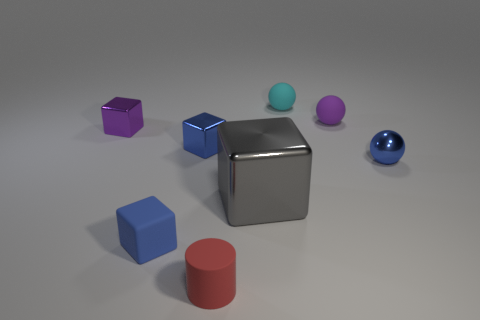Is there any other thing that has the same size as the gray object?
Your answer should be very brief. No. Is the number of cyan spheres in front of the small cyan thing greater than the number of small purple rubber objects?
Provide a succinct answer. No. Do the big metallic object and the red thing have the same shape?
Ensure brevity in your answer.  No. The purple rubber object has what size?
Ensure brevity in your answer.  Small. Is the number of red matte things left of the red matte cylinder greater than the number of tiny metal things that are behind the tiny purple ball?
Ensure brevity in your answer.  No. Are there any tiny purple objects on the right side of the tiny red rubber object?
Your answer should be very brief. Yes. Are there any yellow rubber balls of the same size as the blue metal ball?
Keep it short and to the point. No. The large thing that is the same material as the small purple block is what color?
Your answer should be very brief. Gray. What is the material of the purple ball?
Offer a very short reply. Rubber. The gray shiny object is what shape?
Offer a terse response. Cube. 